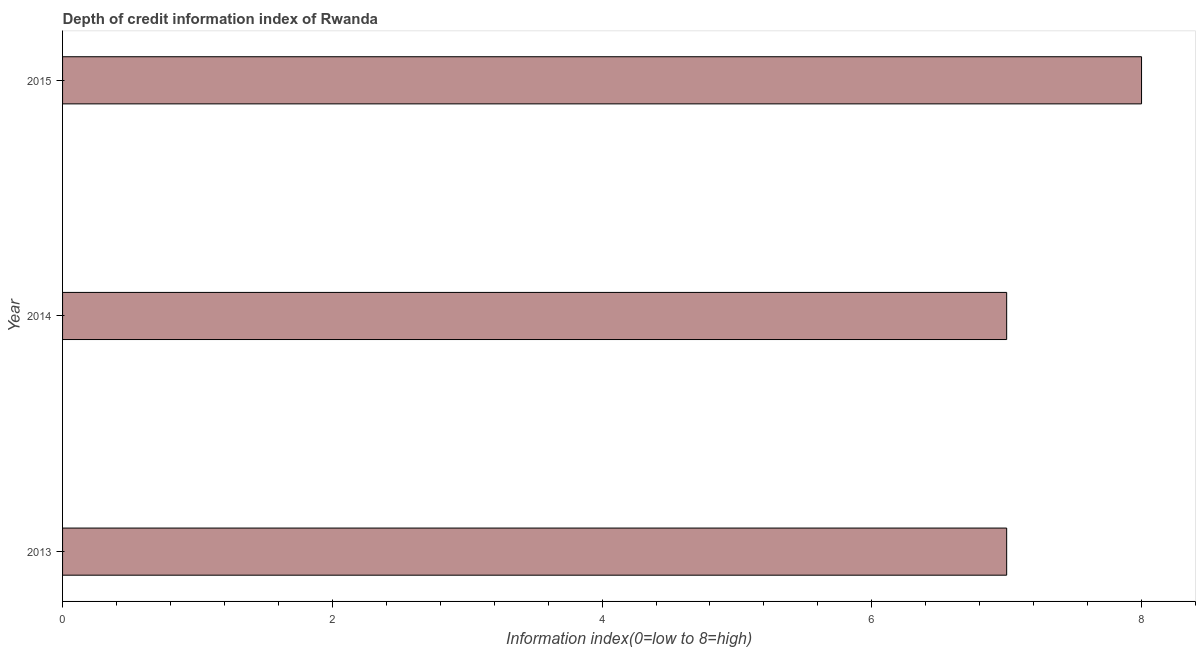Does the graph contain any zero values?
Make the answer very short. No. What is the title of the graph?
Provide a short and direct response. Depth of credit information index of Rwanda. What is the label or title of the X-axis?
Offer a terse response. Information index(0=low to 8=high). What is the label or title of the Y-axis?
Offer a terse response. Year. What is the depth of credit information index in 2014?
Give a very brief answer. 7. Across all years, what is the minimum depth of credit information index?
Your answer should be very brief. 7. In which year was the depth of credit information index maximum?
Provide a succinct answer. 2015. In which year was the depth of credit information index minimum?
Provide a succinct answer. 2013. What is the sum of the depth of credit information index?
Your answer should be very brief. 22. What is the difference between the depth of credit information index in 2014 and 2015?
Ensure brevity in your answer.  -1. What is the average depth of credit information index per year?
Your response must be concise. 7. What is the median depth of credit information index?
Your answer should be compact. 7. In how many years, is the depth of credit information index greater than 0.8 ?
Provide a succinct answer. 3. Do a majority of the years between 2015 and 2013 (inclusive) have depth of credit information index greater than 0.8 ?
Ensure brevity in your answer.  Yes. What is the ratio of the depth of credit information index in 2014 to that in 2015?
Give a very brief answer. 0.88. What is the difference between the highest and the second highest depth of credit information index?
Your answer should be compact. 1. Are all the bars in the graph horizontal?
Your answer should be very brief. Yes. How many years are there in the graph?
Keep it short and to the point. 3. What is the difference between two consecutive major ticks on the X-axis?
Make the answer very short. 2. Are the values on the major ticks of X-axis written in scientific E-notation?
Provide a short and direct response. No. What is the difference between the Information index(0=low to 8=high) in 2013 and 2014?
Provide a short and direct response. 0. What is the difference between the Information index(0=low to 8=high) in 2013 and 2015?
Ensure brevity in your answer.  -1. What is the ratio of the Information index(0=low to 8=high) in 2014 to that in 2015?
Offer a very short reply. 0.88. 